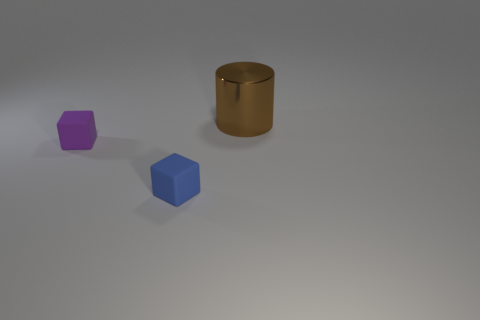Is there another brown cylinder that has the same size as the cylinder?
Provide a short and direct response. No. Do the large metallic object and the small blue object have the same shape?
Keep it short and to the point. No. Are there any blue matte objects that are on the left side of the tiny matte block that is behind the cube that is in front of the tiny purple object?
Your response must be concise. No. What number of other objects are there of the same color as the big metallic object?
Offer a terse response. 0. There is a matte object that is behind the tiny blue thing; is its size the same as the brown metallic object that is right of the small blue object?
Provide a short and direct response. No. Are there the same number of big brown objects that are right of the tiny purple object and big brown cylinders on the left side of the blue rubber cube?
Provide a short and direct response. No. Is there anything else that is made of the same material as the brown cylinder?
Ensure brevity in your answer.  No. Does the blue thing have the same size as the cube that is to the left of the tiny blue object?
Your answer should be compact. Yes. There is a tiny block that is to the left of the tiny rubber block to the right of the purple rubber cube; what is its material?
Keep it short and to the point. Rubber. Are there an equal number of blue objects behind the purple matte block and large red objects?
Provide a succinct answer. Yes. 